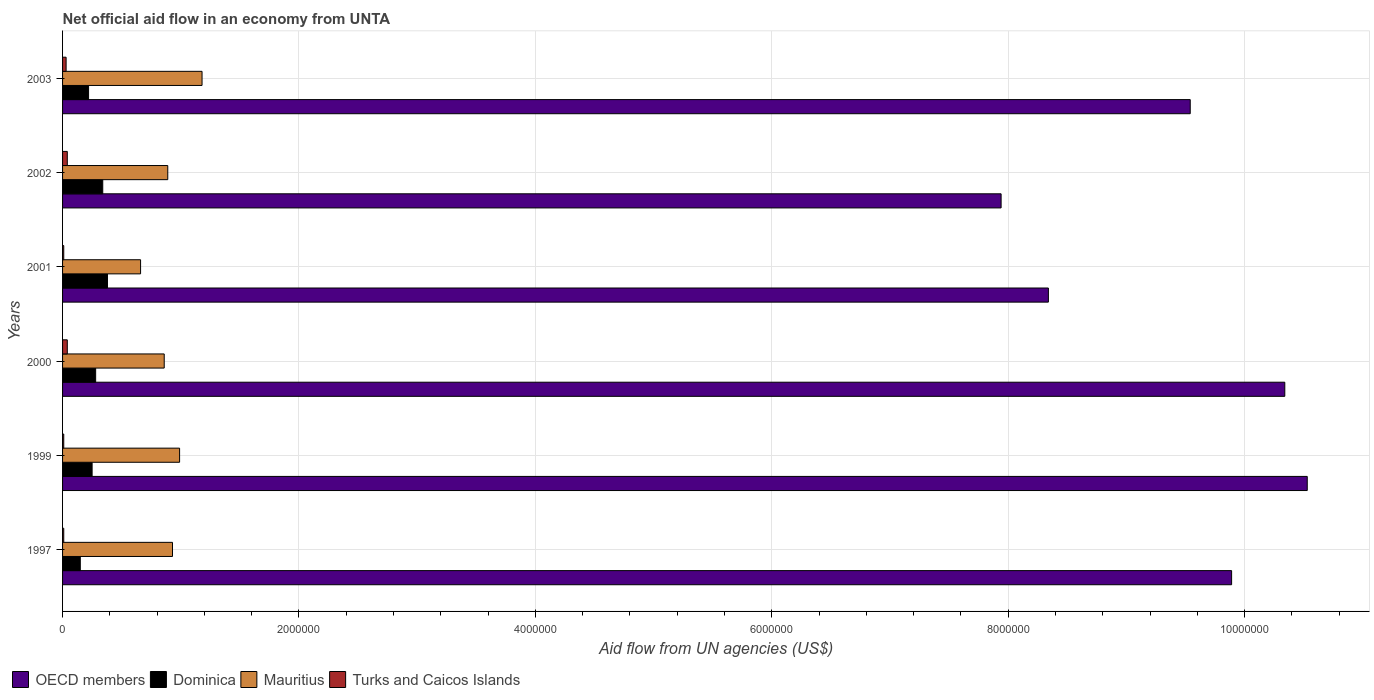How many different coloured bars are there?
Your response must be concise. 4. How many groups of bars are there?
Give a very brief answer. 6. How many bars are there on the 3rd tick from the top?
Offer a terse response. 4. What is the label of the 2nd group of bars from the top?
Provide a short and direct response. 2002. In how many cases, is the number of bars for a given year not equal to the number of legend labels?
Make the answer very short. 0. What is the net official aid flow in Mauritius in 1999?
Your response must be concise. 9.90e+05. Across all years, what is the maximum net official aid flow in Dominica?
Keep it short and to the point. 3.80e+05. Across all years, what is the minimum net official aid flow in Mauritius?
Provide a succinct answer. 6.60e+05. In which year was the net official aid flow in Turks and Caicos Islands minimum?
Ensure brevity in your answer.  1997. What is the total net official aid flow in OECD members in the graph?
Give a very brief answer. 5.66e+07. What is the difference between the net official aid flow in OECD members in 2001 and that in 2002?
Provide a succinct answer. 4.00e+05. What is the difference between the net official aid flow in Turks and Caicos Islands in 2001 and the net official aid flow in OECD members in 2003?
Your answer should be very brief. -9.53e+06. What is the average net official aid flow in Mauritius per year?
Offer a very short reply. 9.18e+05. In the year 1999, what is the difference between the net official aid flow in Mauritius and net official aid flow in Turks and Caicos Islands?
Offer a terse response. 9.80e+05. In how many years, is the net official aid flow in OECD members greater than 10000000 US$?
Ensure brevity in your answer.  2. What is the ratio of the net official aid flow in Mauritius in 1997 to that in 2002?
Offer a very short reply. 1.04. Is the difference between the net official aid flow in Mauritius in 1997 and 2002 greater than the difference between the net official aid flow in Turks and Caicos Islands in 1997 and 2002?
Give a very brief answer. Yes. What is the difference between the highest and the lowest net official aid flow in Turks and Caicos Islands?
Offer a terse response. 3.00e+04. In how many years, is the net official aid flow in Mauritius greater than the average net official aid flow in Mauritius taken over all years?
Offer a very short reply. 3. Is the sum of the net official aid flow in Mauritius in 1999 and 2003 greater than the maximum net official aid flow in OECD members across all years?
Keep it short and to the point. No. Is it the case that in every year, the sum of the net official aid flow in Dominica and net official aid flow in Mauritius is greater than the sum of net official aid flow in OECD members and net official aid flow in Turks and Caicos Islands?
Your answer should be compact. Yes. What does the 4th bar from the top in 2000 represents?
Your answer should be very brief. OECD members. What does the 3rd bar from the bottom in 1997 represents?
Your response must be concise. Mauritius. What is the title of the graph?
Your response must be concise. Net official aid flow in an economy from UNTA. What is the label or title of the X-axis?
Your answer should be compact. Aid flow from UN agencies (US$). What is the Aid flow from UN agencies (US$) of OECD members in 1997?
Provide a succinct answer. 9.89e+06. What is the Aid flow from UN agencies (US$) in Dominica in 1997?
Give a very brief answer. 1.50e+05. What is the Aid flow from UN agencies (US$) of Mauritius in 1997?
Your response must be concise. 9.30e+05. What is the Aid flow from UN agencies (US$) of OECD members in 1999?
Offer a very short reply. 1.05e+07. What is the Aid flow from UN agencies (US$) in Dominica in 1999?
Offer a very short reply. 2.50e+05. What is the Aid flow from UN agencies (US$) of Mauritius in 1999?
Your answer should be compact. 9.90e+05. What is the Aid flow from UN agencies (US$) of Turks and Caicos Islands in 1999?
Offer a very short reply. 10000. What is the Aid flow from UN agencies (US$) of OECD members in 2000?
Ensure brevity in your answer.  1.03e+07. What is the Aid flow from UN agencies (US$) in Dominica in 2000?
Ensure brevity in your answer.  2.80e+05. What is the Aid flow from UN agencies (US$) of Mauritius in 2000?
Your response must be concise. 8.60e+05. What is the Aid flow from UN agencies (US$) of Turks and Caicos Islands in 2000?
Your answer should be very brief. 4.00e+04. What is the Aid flow from UN agencies (US$) of OECD members in 2001?
Give a very brief answer. 8.34e+06. What is the Aid flow from UN agencies (US$) of Dominica in 2001?
Your answer should be compact. 3.80e+05. What is the Aid flow from UN agencies (US$) of Mauritius in 2001?
Your answer should be very brief. 6.60e+05. What is the Aid flow from UN agencies (US$) of OECD members in 2002?
Provide a succinct answer. 7.94e+06. What is the Aid flow from UN agencies (US$) in Dominica in 2002?
Your answer should be compact. 3.40e+05. What is the Aid flow from UN agencies (US$) of Mauritius in 2002?
Your answer should be compact. 8.90e+05. What is the Aid flow from UN agencies (US$) of Turks and Caicos Islands in 2002?
Offer a terse response. 4.00e+04. What is the Aid flow from UN agencies (US$) in OECD members in 2003?
Keep it short and to the point. 9.54e+06. What is the Aid flow from UN agencies (US$) in Mauritius in 2003?
Your response must be concise. 1.18e+06. What is the Aid flow from UN agencies (US$) in Turks and Caicos Islands in 2003?
Your answer should be very brief. 3.00e+04. Across all years, what is the maximum Aid flow from UN agencies (US$) in OECD members?
Provide a succinct answer. 1.05e+07. Across all years, what is the maximum Aid flow from UN agencies (US$) in Mauritius?
Ensure brevity in your answer.  1.18e+06. Across all years, what is the maximum Aid flow from UN agencies (US$) in Turks and Caicos Islands?
Your response must be concise. 4.00e+04. Across all years, what is the minimum Aid flow from UN agencies (US$) of OECD members?
Make the answer very short. 7.94e+06. What is the total Aid flow from UN agencies (US$) in OECD members in the graph?
Keep it short and to the point. 5.66e+07. What is the total Aid flow from UN agencies (US$) in Dominica in the graph?
Ensure brevity in your answer.  1.62e+06. What is the total Aid flow from UN agencies (US$) of Mauritius in the graph?
Offer a very short reply. 5.51e+06. What is the difference between the Aid flow from UN agencies (US$) in OECD members in 1997 and that in 1999?
Ensure brevity in your answer.  -6.40e+05. What is the difference between the Aid flow from UN agencies (US$) of OECD members in 1997 and that in 2000?
Offer a very short reply. -4.50e+05. What is the difference between the Aid flow from UN agencies (US$) of Mauritius in 1997 and that in 2000?
Make the answer very short. 7.00e+04. What is the difference between the Aid flow from UN agencies (US$) in Turks and Caicos Islands in 1997 and that in 2000?
Offer a very short reply. -3.00e+04. What is the difference between the Aid flow from UN agencies (US$) in OECD members in 1997 and that in 2001?
Ensure brevity in your answer.  1.55e+06. What is the difference between the Aid flow from UN agencies (US$) of OECD members in 1997 and that in 2002?
Offer a very short reply. 1.95e+06. What is the difference between the Aid flow from UN agencies (US$) of Turks and Caicos Islands in 1997 and that in 2002?
Your response must be concise. -3.00e+04. What is the difference between the Aid flow from UN agencies (US$) of OECD members in 1997 and that in 2003?
Offer a very short reply. 3.50e+05. What is the difference between the Aid flow from UN agencies (US$) of Mauritius in 1997 and that in 2003?
Keep it short and to the point. -2.50e+05. What is the difference between the Aid flow from UN agencies (US$) of OECD members in 1999 and that in 2000?
Offer a very short reply. 1.90e+05. What is the difference between the Aid flow from UN agencies (US$) in Dominica in 1999 and that in 2000?
Ensure brevity in your answer.  -3.00e+04. What is the difference between the Aid flow from UN agencies (US$) of Turks and Caicos Islands in 1999 and that in 2000?
Provide a succinct answer. -3.00e+04. What is the difference between the Aid flow from UN agencies (US$) of OECD members in 1999 and that in 2001?
Offer a very short reply. 2.19e+06. What is the difference between the Aid flow from UN agencies (US$) in Turks and Caicos Islands in 1999 and that in 2001?
Ensure brevity in your answer.  0. What is the difference between the Aid flow from UN agencies (US$) in OECD members in 1999 and that in 2002?
Make the answer very short. 2.59e+06. What is the difference between the Aid flow from UN agencies (US$) in Dominica in 1999 and that in 2002?
Provide a succinct answer. -9.00e+04. What is the difference between the Aid flow from UN agencies (US$) of Mauritius in 1999 and that in 2002?
Your response must be concise. 1.00e+05. What is the difference between the Aid flow from UN agencies (US$) in OECD members in 1999 and that in 2003?
Your answer should be compact. 9.90e+05. What is the difference between the Aid flow from UN agencies (US$) of Turks and Caicos Islands in 1999 and that in 2003?
Provide a short and direct response. -2.00e+04. What is the difference between the Aid flow from UN agencies (US$) of OECD members in 2000 and that in 2001?
Give a very brief answer. 2.00e+06. What is the difference between the Aid flow from UN agencies (US$) of Dominica in 2000 and that in 2001?
Provide a succinct answer. -1.00e+05. What is the difference between the Aid flow from UN agencies (US$) of Turks and Caicos Islands in 2000 and that in 2001?
Offer a very short reply. 3.00e+04. What is the difference between the Aid flow from UN agencies (US$) of OECD members in 2000 and that in 2002?
Give a very brief answer. 2.40e+06. What is the difference between the Aid flow from UN agencies (US$) of Dominica in 2000 and that in 2003?
Offer a terse response. 6.00e+04. What is the difference between the Aid flow from UN agencies (US$) of Mauritius in 2000 and that in 2003?
Provide a short and direct response. -3.20e+05. What is the difference between the Aid flow from UN agencies (US$) of OECD members in 2001 and that in 2002?
Your response must be concise. 4.00e+05. What is the difference between the Aid flow from UN agencies (US$) of Dominica in 2001 and that in 2002?
Provide a short and direct response. 4.00e+04. What is the difference between the Aid flow from UN agencies (US$) of Mauritius in 2001 and that in 2002?
Offer a terse response. -2.30e+05. What is the difference between the Aid flow from UN agencies (US$) of Turks and Caicos Islands in 2001 and that in 2002?
Your response must be concise. -3.00e+04. What is the difference between the Aid flow from UN agencies (US$) in OECD members in 2001 and that in 2003?
Ensure brevity in your answer.  -1.20e+06. What is the difference between the Aid flow from UN agencies (US$) in Dominica in 2001 and that in 2003?
Your answer should be compact. 1.60e+05. What is the difference between the Aid flow from UN agencies (US$) of Mauritius in 2001 and that in 2003?
Your response must be concise. -5.20e+05. What is the difference between the Aid flow from UN agencies (US$) of OECD members in 2002 and that in 2003?
Your answer should be compact. -1.60e+06. What is the difference between the Aid flow from UN agencies (US$) of Dominica in 2002 and that in 2003?
Ensure brevity in your answer.  1.20e+05. What is the difference between the Aid flow from UN agencies (US$) of Mauritius in 2002 and that in 2003?
Keep it short and to the point. -2.90e+05. What is the difference between the Aid flow from UN agencies (US$) of OECD members in 1997 and the Aid flow from UN agencies (US$) of Dominica in 1999?
Offer a very short reply. 9.64e+06. What is the difference between the Aid flow from UN agencies (US$) of OECD members in 1997 and the Aid flow from UN agencies (US$) of Mauritius in 1999?
Ensure brevity in your answer.  8.90e+06. What is the difference between the Aid flow from UN agencies (US$) in OECD members in 1997 and the Aid flow from UN agencies (US$) in Turks and Caicos Islands in 1999?
Offer a terse response. 9.88e+06. What is the difference between the Aid flow from UN agencies (US$) in Dominica in 1997 and the Aid flow from UN agencies (US$) in Mauritius in 1999?
Provide a succinct answer. -8.40e+05. What is the difference between the Aid flow from UN agencies (US$) in Dominica in 1997 and the Aid flow from UN agencies (US$) in Turks and Caicos Islands in 1999?
Provide a succinct answer. 1.40e+05. What is the difference between the Aid flow from UN agencies (US$) in Mauritius in 1997 and the Aid flow from UN agencies (US$) in Turks and Caicos Islands in 1999?
Your answer should be very brief. 9.20e+05. What is the difference between the Aid flow from UN agencies (US$) in OECD members in 1997 and the Aid flow from UN agencies (US$) in Dominica in 2000?
Your answer should be compact. 9.61e+06. What is the difference between the Aid flow from UN agencies (US$) of OECD members in 1997 and the Aid flow from UN agencies (US$) of Mauritius in 2000?
Give a very brief answer. 9.03e+06. What is the difference between the Aid flow from UN agencies (US$) in OECD members in 1997 and the Aid flow from UN agencies (US$) in Turks and Caicos Islands in 2000?
Provide a succinct answer. 9.85e+06. What is the difference between the Aid flow from UN agencies (US$) of Dominica in 1997 and the Aid flow from UN agencies (US$) of Mauritius in 2000?
Your answer should be compact. -7.10e+05. What is the difference between the Aid flow from UN agencies (US$) of Dominica in 1997 and the Aid flow from UN agencies (US$) of Turks and Caicos Islands in 2000?
Keep it short and to the point. 1.10e+05. What is the difference between the Aid flow from UN agencies (US$) of Mauritius in 1997 and the Aid flow from UN agencies (US$) of Turks and Caicos Islands in 2000?
Give a very brief answer. 8.90e+05. What is the difference between the Aid flow from UN agencies (US$) of OECD members in 1997 and the Aid flow from UN agencies (US$) of Dominica in 2001?
Your response must be concise. 9.51e+06. What is the difference between the Aid flow from UN agencies (US$) of OECD members in 1997 and the Aid flow from UN agencies (US$) of Mauritius in 2001?
Provide a succinct answer. 9.23e+06. What is the difference between the Aid flow from UN agencies (US$) in OECD members in 1997 and the Aid flow from UN agencies (US$) in Turks and Caicos Islands in 2001?
Provide a succinct answer. 9.88e+06. What is the difference between the Aid flow from UN agencies (US$) in Dominica in 1997 and the Aid flow from UN agencies (US$) in Mauritius in 2001?
Ensure brevity in your answer.  -5.10e+05. What is the difference between the Aid flow from UN agencies (US$) in Dominica in 1997 and the Aid flow from UN agencies (US$) in Turks and Caicos Islands in 2001?
Ensure brevity in your answer.  1.40e+05. What is the difference between the Aid flow from UN agencies (US$) of Mauritius in 1997 and the Aid flow from UN agencies (US$) of Turks and Caicos Islands in 2001?
Give a very brief answer. 9.20e+05. What is the difference between the Aid flow from UN agencies (US$) in OECD members in 1997 and the Aid flow from UN agencies (US$) in Dominica in 2002?
Offer a very short reply. 9.55e+06. What is the difference between the Aid flow from UN agencies (US$) of OECD members in 1997 and the Aid flow from UN agencies (US$) of Mauritius in 2002?
Ensure brevity in your answer.  9.00e+06. What is the difference between the Aid flow from UN agencies (US$) of OECD members in 1997 and the Aid flow from UN agencies (US$) of Turks and Caicos Islands in 2002?
Provide a short and direct response. 9.85e+06. What is the difference between the Aid flow from UN agencies (US$) in Dominica in 1997 and the Aid flow from UN agencies (US$) in Mauritius in 2002?
Provide a short and direct response. -7.40e+05. What is the difference between the Aid flow from UN agencies (US$) of Dominica in 1997 and the Aid flow from UN agencies (US$) of Turks and Caicos Islands in 2002?
Keep it short and to the point. 1.10e+05. What is the difference between the Aid flow from UN agencies (US$) of Mauritius in 1997 and the Aid flow from UN agencies (US$) of Turks and Caicos Islands in 2002?
Provide a succinct answer. 8.90e+05. What is the difference between the Aid flow from UN agencies (US$) of OECD members in 1997 and the Aid flow from UN agencies (US$) of Dominica in 2003?
Provide a succinct answer. 9.67e+06. What is the difference between the Aid flow from UN agencies (US$) of OECD members in 1997 and the Aid flow from UN agencies (US$) of Mauritius in 2003?
Your answer should be compact. 8.71e+06. What is the difference between the Aid flow from UN agencies (US$) in OECD members in 1997 and the Aid flow from UN agencies (US$) in Turks and Caicos Islands in 2003?
Your answer should be very brief. 9.86e+06. What is the difference between the Aid flow from UN agencies (US$) of Dominica in 1997 and the Aid flow from UN agencies (US$) of Mauritius in 2003?
Your response must be concise. -1.03e+06. What is the difference between the Aid flow from UN agencies (US$) in Dominica in 1997 and the Aid flow from UN agencies (US$) in Turks and Caicos Islands in 2003?
Ensure brevity in your answer.  1.20e+05. What is the difference between the Aid flow from UN agencies (US$) in Mauritius in 1997 and the Aid flow from UN agencies (US$) in Turks and Caicos Islands in 2003?
Your answer should be very brief. 9.00e+05. What is the difference between the Aid flow from UN agencies (US$) in OECD members in 1999 and the Aid flow from UN agencies (US$) in Dominica in 2000?
Give a very brief answer. 1.02e+07. What is the difference between the Aid flow from UN agencies (US$) of OECD members in 1999 and the Aid flow from UN agencies (US$) of Mauritius in 2000?
Ensure brevity in your answer.  9.67e+06. What is the difference between the Aid flow from UN agencies (US$) of OECD members in 1999 and the Aid flow from UN agencies (US$) of Turks and Caicos Islands in 2000?
Keep it short and to the point. 1.05e+07. What is the difference between the Aid flow from UN agencies (US$) of Dominica in 1999 and the Aid flow from UN agencies (US$) of Mauritius in 2000?
Your answer should be compact. -6.10e+05. What is the difference between the Aid flow from UN agencies (US$) in Mauritius in 1999 and the Aid flow from UN agencies (US$) in Turks and Caicos Islands in 2000?
Keep it short and to the point. 9.50e+05. What is the difference between the Aid flow from UN agencies (US$) in OECD members in 1999 and the Aid flow from UN agencies (US$) in Dominica in 2001?
Offer a terse response. 1.02e+07. What is the difference between the Aid flow from UN agencies (US$) in OECD members in 1999 and the Aid flow from UN agencies (US$) in Mauritius in 2001?
Keep it short and to the point. 9.87e+06. What is the difference between the Aid flow from UN agencies (US$) in OECD members in 1999 and the Aid flow from UN agencies (US$) in Turks and Caicos Islands in 2001?
Give a very brief answer. 1.05e+07. What is the difference between the Aid flow from UN agencies (US$) of Dominica in 1999 and the Aid flow from UN agencies (US$) of Mauritius in 2001?
Give a very brief answer. -4.10e+05. What is the difference between the Aid flow from UN agencies (US$) of Dominica in 1999 and the Aid flow from UN agencies (US$) of Turks and Caicos Islands in 2001?
Offer a terse response. 2.40e+05. What is the difference between the Aid flow from UN agencies (US$) in Mauritius in 1999 and the Aid flow from UN agencies (US$) in Turks and Caicos Islands in 2001?
Offer a very short reply. 9.80e+05. What is the difference between the Aid flow from UN agencies (US$) of OECD members in 1999 and the Aid flow from UN agencies (US$) of Dominica in 2002?
Your answer should be compact. 1.02e+07. What is the difference between the Aid flow from UN agencies (US$) in OECD members in 1999 and the Aid flow from UN agencies (US$) in Mauritius in 2002?
Give a very brief answer. 9.64e+06. What is the difference between the Aid flow from UN agencies (US$) of OECD members in 1999 and the Aid flow from UN agencies (US$) of Turks and Caicos Islands in 2002?
Provide a succinct answer. 1.05e+07. What is the difference between the Aid flow from UN agencies (US$) in Dominica in 1999 and the Aid flow from UN agencies (US$) in Mauritius in 2002?
Make the answer very short. -6.40e+05. What is the difference between the Aid flow from UN agencies (US$) in Dominica in 1999 and the Aid flow from UN agencies (US$) in Turks and Caicos Islands in 2002?
Offer a very short reply. 2.10e+05. What is the difference between the Aid flow from UN agencies (US$) in Mauritius in 1999 and the Aid flow from UN agencies (US$) in Turks and Caicos Islands in 2002?
Provide a short and direct response. 9.50e+05. What is the difference between the Aid flow from UN agencies (US$) of OECD members in 1999 and the Aid flow from UN agencies (US$) of Dominica in 2003?
Offer a very short reply. 1.03e+07. What is the difference between the Aid flow from UN agencies (US$) of OECD members in 1999 and the Aid flow from UN agencies (US$) of Mauritius in 2003?
Your response must be concise. 9.35e+06. What is the difference between the Aid flow from UN agencies (US$) of OECD members in 1999 and the Aid flow from UN agencies (US$) of Turks and Caicos Islands in 2003?
Offer a terse response. 1.05e+07. What is the difference between the Aid flow from UN agencies (US$) of Dominica in 1999 and the Aid flow from UN agencies (US$) of Mauritius in 2003?
Provide a short and direct response. -9.30e+05. What is the difference between the Aid flow from UN agencies (US$) of Mauritius in 1999 and the Aid flow from UN agencies (US$) of Turks and Caicos Islands in 2003?
Provide a short and direct response. 9.60e+05. What is the difference between the Aid flow from UN agencies (US$) in OECD members in 2000 and the Aid flow from UN agencies (US$) in Dominica in 2001?
Your answer should be compact. 9.96e+06. What is the difference between the Aid flow from UN agencies (US$) in OECD members in 2000 and the Aid flow from UN agencies (US$) in Mauritius in 2001?
Give a very brief answer. 9.68e+06. What is the difference between the Aid flow from UN agencies (US$) in OECD members in 2000 and the Aid flow from UN agencies (US$) in Turks and Caicos Islands in 2001?
Your answer should be compact. 1.03e+07. What is the difference between the Aid flow from UN agencies (US$) of Dominica in 2000 and the Aid flow from UN agencies (US$) of Mauritius in 2001?
Make the answer very short. -3.80e+05. What is the difference between the Aid flow from UN agencies (US$) in Dominica in 2000 and the Aid flow from UN agencies (US$) in Turks and Caicos Islands in 2001?
Provide a succinct answer. 2.70e+05. What is the difference between the Aid flow from UN agencies (US$) of Mauritius in 2000 and the Aid flow from UN agencies (US$) of Turks and Caicos Islands in 2001?
Ensure brevity in your answer.  8.50e+05. What is the difference between the Aid flow from UN agencies (US$) in OECD members in 2000 and the Aid flow from UN agencies (US$) in Mauritius in 2002?
Give a very brief answer. 9.45e+06. What is the difference between the Aid flow from UN agencies (US$) of OECD members in 2000 and the Aid flow from UN agencies (US$) of Turks and Caicos Islands in 2002?
Provide a short and direct response. 1.03e+07. What is the difference between the Aid flow from UN agencies (US$) in Dominica in 2000 and the Aid flow from UN agencies (US$) in Mauritius in 2002?
Give a very brief answer. -6.10e+05. What is the difference between the Aid flow from UN agencies (US$) in Dominica in 2000 and the Aid flow from UN agencies (US$) in Turks and Caicos Islands in 2002?
Your response must be concise. 2.40e+05. What is the difference between the Aid flow from UN agencies (US$) in Mauritius in 2000 and the Aid flow from UN agencies (US$) in Turks and Caicos Islands in 2002?
Keep it short and to the point. 8.20e+05. What is the difference between the Aid flow from UN agencies (US$) of OECD members in 2000 and the Aid flow from UN agencies (US$) of Dominica in 2003?
Make the answer very short. 1.01e+07. What is the difference between the Aid flow from UN agencies (US$) in OECD members in 2000 and the Aid flow from UN agencies (US$) in Mauritius in 2003?
Provide a short and direct response. 9.16e+06. What is the difference between the Aid flow from UN agencies (US$) of OECD members in 2000 and the Aid flow from UN agencies (US$) of Turks and Caicos Islands in 2003?
Make the answer very short. 1.03e+07. What is the difference between the Aid flow from UN agencies (US$) in Dominica in 2000 and the Aid flow from UN agencies (US$) in Mauritius in 2003?
Offer a terse response. -9.00e+05. What is the difference between the Aid flow from UN agencies (US$) of Mauritius in 2000 and the Aid flow from UN agencies (US$) of Turks and Caicos Islands in 2003?
Provide a short and direct response. 8.30e+05. What is the difference between the Aid flow from UN agencies (US$) in OECD members in 2001 and the Aid flow from UN agencies (US$) in Dominica in 2002?
Provide a succinct answer. 8.00e+06. What is the difference between the Aid flow from UN agencies (US$) in OECD members in 2001 and the Aid flow from UN agencies (US$) in Mauritius in 2002?
Your response must be concise. 7.45e+06. What is the difference between the Aid flow from UN agencies (US$) in OECD members in 2001 and the Aid flow from UN agencies (US$) in Turks and Caicos Islands in 2002?
Offer a terse response. 8.30e+06. What is the difference between the Aid flow from UN agencies (US$) of Dominica in 2001 and the Aid flow from UN agencies (US$) of Mauritius in 2002?
Offer a terse response. -5.10e+05. What is the difference between the Aid flow from UN agencies (US$) of Dominica in 2001 and the Aid flow from UN agencies (US$) of Turks and Caicos Islands in 2002?
Your response must be concise. 3.40e+05. What is the difference between the Aid flow from UN agencies (US$) of Mauritius in 2001 and the Aid flow from UN agencies (US$) of Turks and Caicos Islands in 2002?
Ensure brevity in your answer.  6.20e+05. What is the difference between the Aid flow from UN agencies (US$) in OECD members in 2001 and the Aid flow from UN agencies (US$) in Dominica in 2003?
Offer a very short reply. 8.12e+06. What is the difference between the Aid flow from UN agencies (US$) in OECD members in 2001 and the Aid flow from UN agencies (US$) in Mauritius in 2003?
Offer a very short reply. 7.16e+06. What is the difference between the Aid flow from UN agencies (US$) of OECD members in 2001 and the Aid flow from UN agencies (US$) of Turks and Caicos Islands in 2003?
Keep it short and to the point. 8.31e+06. What is the difference between the Aid flow from UN agencies (US$) in Dominica in 2001 and the Aid flow from UN agencies (US$) in Mauritius in 2003?
Provide a succinct answer. -8.00e+05. What is the difference between the Aid flow from UN agencies (US$) of Dominica in 2001 and the Aid flow from UN agencies (US$) of Turks and Caicos Islands in 2003?
Make the answer very short. 3.50e+05. What is the difference between the Aid flow from UN agencies (US$) of Mauritius in 2001 and the Aid flow from UN agencies (US$) of Turks and Caicos Islands in 2003?
Ensure brevity in your answer.  6.30e+05. What is the difference between the Aid flow from UN agencies (US$) in OECD members in 2002 and the Aid flow from UN agencies (US$) in Dominica in 2003?
Keep it short and to the point. 7.72e+06. What is the difference between the Aid flow from UN agencies (US$) of OECD members in 2002 and the Aid flow from UN agencies (US$) of Mauritius in 2003?
Your answer should be very brief. 6.76e+06. What is the difference between the Aid flow from UN agencies (US$) of OECD members in 2002 and the Aid flow from UN agencies (US$) of Turks and Caicos Islands in 2003?
Offer a terse response. 7.91e+06. What is the difference between the Aid flow from UN agencies (US$) in Dominica in 2002 and the Aid flow from UN agencies (US$) in Mauritius in 2003?
Ensure brevity in your answer.  -8.40e+05. What is the difference between the Aid flow from UN agencies (US$) of Mauritius in 2002 and the Aid flow from UN agencies (US$) of Turks and Caicos Islands in 2003?
Offer a very short reply. 8.60e+05. What is the average Aid flow from UN agencies (US$) in OECD members per year?
Provide a short and direct response. 9.43e+06. What is the average Aid flow from UN agencies (US$) of Dominica per year?
Provide a short and direct response. 2.70e+05. What is the average Aid flow from UN agencies (US$) in Mauritius per year?
Offer a very short reply. 9.18e+05. What is the average Aid flow from UN agencies (US$) in Turks and Caicos Islands per year?
Your response must be concise. 2.33e+04. In the year 1997, what is the difference between the Aid flow from UN agencies (US$) of OECD members and Aid flow from UN agencies (US$) of Dominica?
Give a very brief answer. 9.74e+06. In the year 1997, what is the difference between the Aid flow from UN agencies (US$) of OECD members and Aid flow from UN agencies (US$) of Mauritius?
Ensure brevity in your answer.  8.96e+06. In the year 1997, what is the difference between the Aid flow from UN agencies (US$) of OECD members and Aid flow from UN agencies (US$) of Turks and Caicos Islands?
Your response must be concise. 9.88e+06. In the year 1997, what is the difference between the Aid flow from UN agencies (US$) in Dominica and Aid flow from UN agencies (US$) in Mauritius?
Your response must be concise. -7.80e+05. In the year 1997, what is the difference between the Aid flow from UN agencies (US$) in Dominica and Aid flow from UN agencies (US$) in Turks and Caicos Islands?
Offer a very short reply. 1.40e+05. In the year 1997, what is the difference between the Aid flow from UN agencies (US$) in Mauritius and Aid flow from UN agencies (US$) in Turks and Caicos Islands?
Offer a terse response. 9.20e+05. In the year 1999, what is the difference between the Aid flow from UN agencies (US$) of OECD members and Aid flow from UN agencies (US$) of Dominica?
Offer a terse response. 1.03e+07. In the year 1999, what is the difference between the Aid flow from UN agencies (US$) in OECD members and Aid flow from UN agencies (US$) in Mauritius?
Offer a terse response. 9.54e+06. In the year 1999, what is the difference between the Aid flow from UN agencies (US$) of OECD members and Aid flow from UN agencies (US$) of Turks and Caicos Islands?
Provide a short and direct response. 1.05e+07. In the year 1999, what is the difference between the Aid flow from UN agencies (US$) in Dominica and Aid flow from UN agencies (US$) in Mauritius?
Your response must be concise. -7.40e+05. In the year 1999, what is the difference between the Aid flow from UN agencies (US$) in Mauritius and Aid flow from UN agencies (US$) in Turks and Caicos Islands?
Provide a short and direct response. 9.80e+05. In the year 2000, what is the difference between the Aid flow from UN agencies (US$) in OECD members and Aid flow from UN agencies (US$) in Dominica?
Your answer should be very brief. 1.01e+07. In the year 2000, what is the difference between the Aid flow from UN agencies (US$) in OECD members and Aid flow from UN agencies (US$) in Mauritius?
Keep it short and to the point. 9.48e+06. In the year 2000, what is the difference between the Aid flow from UN agencies (US$) in OECD members and Aid flow from UN agencies (US$) in Turks and Caicos Islands?
Your answer should be compact. 1.03e+07. In the year 2000, what is the difference between the Aid flow from UN agencies (US$) in Dominica and Aid flow from UN agencies (US$) in Mauritius?
Provide a succinct answer. -5.80e+05. In the year 2000, what is the difference between the Aid flow from UN agencies (US$) in Dominica and Aid flow from UN agencies (US$) in Turks and Caicos Islands?
Make the answer very short. 2.40e+05. In the year 2000, what is the difference between the Aid flow from UN agencies (US$) in Mauritius and Aid flow from UN agencies (US$) in Turks and Caicos Islands?
Your answer should be very brief. 8.20e+05. In the year 2001, what is the difference between the Aid flow from UN agencies (US$) in OECD members and Aid flow from UN agencies (US$) in Dominica?
Give a very brief answer. 7.96e+06. In the year 2001, what is the difference between the Aid flow from UN agencies (US$) of OECD members and Aid flow from UN agencies (US$) of Mauritius?
Provide a short and direct response. 7.68e+06. In the year 2001, what is the difference between the Aid flow from UN agencies (US$) in OECD members and Aid flow from UN agencies (US$) in Turks and Caicos Islands?
Keep it short and to the point. 8.33e+06. In the year 2001, what is the difference between the Aid flow from UN agencies (US$) in Dominica and Aid flow from UN agencies (US$) in Mauritius?
Ensure brevity in your answer.  -2.80e+05. In the year 2001, what is the difference between the Aid flow from UN agencies (US$) in Mauritius and Aid flow from UN agencies (US$) in Turks and Caicos Islands?
Give a very brief answer. 6.50e+05. In the year 2002, what is the difference between the Aid flow from UN agencies (US$) in OECD members and Aid flow from UN agencies (US$) in Dominica?
Make the answer very short. 7.60e+06. In the year 2002, what is the difference between the Aid flow from UN agencies (US$) in OECD members and Aid flow from UN agencies (US$) in Mauritius?
Your response must be concise. 7.05e+06. In the year 2002, what is the difference between the Aid flow from UN agencies (US$) of OECD members and Aid flow from UN agencies (US$) of Turks and Caicos Islands?
Your answer should be very brief. 7.90e+06. In the year 2002, what is the difference between the Aid flow from UN agencies (US$) in Dominica and Aid flow from UN agencies (US$) in Mauritius?
Your answer should be compact. -5.50e+05. In the year 2002, what is the difference between the Aid flow from UN agencies (US$) of Mauritius and Aid flow from UN agencies (US$) of Turks and Caicos Islands?
Give a very brief answer. 8.50e+05. In the year 2003, what is the difference between the Aid flow from UN agencies (US$) in OECD members and Aid flow from UN agencies (US$) in Dominica?
Your answer should be compact. 9.32e+06. In the year 2003, what is the difference between the Aid flow from UN agencies (US$) of OECD members and Aid flow from UN agencies (US$) of Mauritius?
Your answer should be very brief. 8.36e+06. In the year 2003, what is the difference between the Aid flow from UN agencies (US$) in OECD members and Aid flow from UN agencies (US$) in Turks and Caicos Islands?
Give a very brief answer. 9.51e+06. In the year 2003, what is the difference between the Aid flow from UN agencies (US$) of Dominica and Aid flow from UN agencies (US$) of Mauritius?
Ensure brevity in your answer.  -9.60e+05. In the year 2003, what is the difference between the Aid flow from UN agencies (US$) in Mauritius and Aid flow from UN agencies (US$) in Turks and Caicos Islands?
Provide a succinct answer. 1.15e+06. What is the ratio of the Aid flow from UN agencies (US$) in OECD members in 1997 to that in 1999?
Give a very brief answer. 0.94. What is the ratio of the Aid flow from UN agencies (US$) of Dominica in 1997 to that in 1999?
Provide a succinct answer. 0.6. What is the ratio of the Aid flow from UN agencies (US$) in Mauritius in 1997 to that in 1999?
Your response must be concise. 0.94. What is the ratio of the Aid flow from UN agencies (US$) in OECD members in 1997 to that in 2000?
Your answer should be compact. 0.96. What is the ratio of the Aid flow from UN agencies (US$) of Dominica in 1997 to that in 2000?
Your answer should be compact. 0.54. What is the ratio of the Aid flow from UN agencies (US$) of Mauritius in 1997 to that in 2000?
Your answer should be compact. 1.08. What is the ratio of the Aid flow from UN agencies (US$) of Turks and Caicos Islands in 1997 to that in 2000?
Give a very brief answer. 0.25. What is the ratio of the Aid flow from UN agencies (US$) of OECD members in 1997 to that in 2001?
Your answer should be compact. 1.19. What is the ratio of the Aid flow from UN agencies (US$) of Dominica in 1997 to that in 2001?
Offer a terse response. 0.39. What is the ratio of the Aid flow from UN agencies (US$) of Mauritius in 1997 to that in 2001?
Provide a succinct answer. 1.41. What is the ratio of the Aid flow from UN agencies (US$) of Turks and Caicos Islands in 1997 to that in 2001?
Give a very brief answer. 1. What is the ratio of the Aid flow from UN agencies (US$) in OECD members in 1997 to that in 2002?
Ensure brevity in your answer.  1.25. What is the ratio of the Aid flow from UN agencies (US$) in Dominica in 1997 to that in 2002?
Keep it short and to the point. 0.44. What is the ratio of the Aid flow from UN agencies (US$) in Mauritius in 1997 to that in 2002?
Keep it short and to the point. 1.04. What is the ratio of the Aid flow from UN agencies (US$) in OECD members in 1997 to that in 2003?
Your answer should be very brief. 1.04. What is the ratio of the Aid flow from UN agencies (US$) in Dominica in 1997 to that in 2003?
Make the answer very short. 0.68. What is the ratio of the Aid flow from UN agencies (US$) of Mauritius in 1997 to that in 2003?
Provide a short and direct response. 0.79. What is the ratio of the Aid flow from UN agencies (US$) of OECD members in 1999 to that in 2000?
Your answer should be compact. 1.02. What is the ratio of the Aid flow from UN agencies (US$) of Dominica in 1999 to that in 2000?
Your answer should be very brief. 0.89. What is the ratio of the Aid flow from UN agencies (US$) of Mauritius in 1999 to that in 2000?
Your answer should be compact. 1.15. What is the ratio of the Aid flow from UN agencies (US$) of Turks and Caicos Islands in 1999 to that in 2000?
Make the answer very short. 0.25. What is the ratio of the Aid flow from UN agencies (US$) in OECD members in 1999 to that in 2001?
Provide a short and direct response. 1.26. What is the ratio of the Aid flow from UN agencies (US$) in Dominica in 1999 to that in 2001?
Ensure brevity in your answer.  0.66. What is the ratio of the Aid flow from UN agencies (US$) of OECD members in 1999 to that in 2002?
Offer a very short reply. 1.33. What is the ratio of the Aid flow from UN agencies (US$) in Dominica in 1999 to that in 2002?
Provide a succinct answer. 0.74. What is the ratio of the Aid flow from UN agencies (US$) in Mauritius in 1999 to that in 2002?
Your answer should be very brief. 1.11. What is the ratio of the Aid flow from UN agencies (US$) in Turks and Caicos Islands in 1999 to that in 2002?
Keep it short and to the point. 0.25. What is the ratio of the Aid flow from UN agencies (US$) of OECD members in 1999 to that in 2003?
Provide a succinct answer. 1.1. What is the ratio of the Aid flow from UN agencies (US$) of Dominica in 1999 to that in 2003?
Provide a succinct answer. 1.14. What is the ratio of the Aid flow from UN agencies (US$) in Mauritius in 1999 to that in 2003?
Offer a terse response. 0.84. What is the ratio of the Aid flow from UN agencies (US$) in OECD members in 2000 to that in 2001?
Offer a terse response. 1.24. What is the ratio of the Aid flow from UN agencies (US$) of Dominica in 2000 to that in 2001?
Offer a very short reply. 0.74. What is the ratio of the Aid flow from UN agencies (US$) in Mauritius in 2000 to that in 2001?
Your answer should be compact. 1.3. What is the ratio of the Aid flow from UN agencies (US$) in Turks and Caicos Islands in 2000 to that in 2001?
Your response must be concise. 4. What is the ratio of the Aid flow from UN agencies (US$) of OECD members in 2000 to that in 2002?
Your answer should be very brief. 1.3. What is the ratio of the Aid flow from UN agencies (US$) of Dominica in 2000 to that in 2002?
Your answer should be compact. 0.82. What is the ratio of the Aid flow from UN agencies (US$) in Mauritius in 2000 to that in 2002?
Provide a succinct answer. 0.97. What is the ratio of the Aid flow from UN agencies (US$) of Turks and Caicos Islands in 2000 to that in 2002?
Provide a short and direct response. 1. What is the ratio of the Aid flow from UN agencies (US$) of OECD members in 2000 to that in 2003?
Give a very brief answer. 1.08. What is the ratio of the Aid flow from UN agencies (US$) of Dominica in 2000 to that in 2003?
Offer a terse response. 1.27. What is the ratio of the Aid flow from UN agencies (US$) in Mauritius in 2000 to that in 2003?
Ensure brevity in your answer.  0.73. What is the ratio of the Aid flow from UN agencies (US$) of Turks and Caicos Islands in 2000 to that in 2003?
Provide a short and direct response. 1.33. What is the ratio of the Aid flow from UN agencies (US$) of OECD members in 2001 to that in 2002?
Ensure brevity in your answer.  1.05. What is the ratio of the Aid flow from UN agencies (US$) in Dominica in 2001 to that in 2002?
Give a very brief answer. 1.12. What is the ratio of the Aid flow from UN agencies (US$) of Mauritius in 2001 to that in 2002?
Your response must be concise. 0.74. What is the ratio of the Aid flow from UN agencies (US$) in OECD members in 2001 to that in 2003?
Make the answer very short. 0.87. What is the ratio of the Aid flow from UN agencies (US$) of Dominica in 2001 to that in 2003?
Your answer should be compact. 1.73. What is the ratio of the Aid flow from UN agencies (US$) in Mauritius in 2001 to that in 2003?
Your response must be concise. 0.56. What is the ratio of the Aid flow from UN agencies (US$) in Turks and Caicos Islands in 2001 to that in 2003?
Make the answer very short. 0.33. What is the ratio of the Aid flow from UN agencies (US$) in OECD members in 2002 to that in 2003?
Give a very brief answer. 0.83. What is the ratio of the Aid flow from UN agencies (US$) of Dominica in 2002 to that in 2003?
Make the answer very short. 1.55. What is the ratio of the Aid flow from UN agencies (US$) of Mauritius in 2002 to that in 2003?
Offer a terse response. 0.75. What is the difference between the highest and the second highest Aid flow from UN agencies (US$) of OECD members?
Your answer should be very brief. 1.90e+05. What is the difference between the highest and the second highest Aid flow from UN agencies (US$) in Turks and Caicos Islands?
Ensure brevity in your answer.  0. What is the difference between the highest and the lowest Aid flow from UN agencies (US$) of OECD members?
Give a very brief answer. 2.59e+06. What is the difference between the highest and the lowest Aid flow from UN agencies (US$) of Mauritius?
Keep it short and to the point. 5.20e+05. What is the difference between the highest and the lowest Aid flow from UN agencies (US$) of Turks and Caicos Islands?
Your response must be concise. 3.00e+04. 